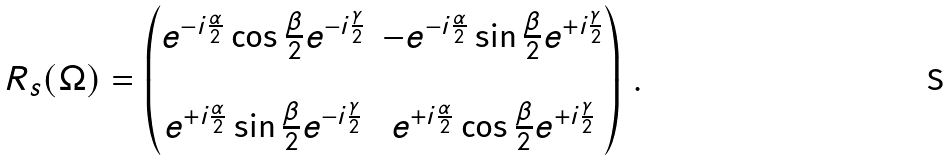Convert formula to latex. <formula><loc_0><loc_0><loc_500><loc_500>R _ { s } ( \Omega ) = \begin{pmatrix} e ^ { - i \frac { \alpha } { 2 } } \cos \frac { \beta } { 2 } e ^ { - i \frac { \gamma } { 2 } } & - e ^ { - i \frac { \alpha } { 2 } } \sin \frac { \beta } { 2 } e ^ { + i \frac { \gamma } { 2 } } \\ \ & \ \\ e ^ { + i \frac { \alpha } { 2 } } \sin \frac { \beta } { 2 } e ^ { - i \frac { \gamma } { 2 } } & e ^ { + i \frac { \alpha } { 2 } } \cos \frac { \beta } { 2 } e ^ { + i \frac { \gamma } { 2 } } \end{pmatrix} \, .</formula> 